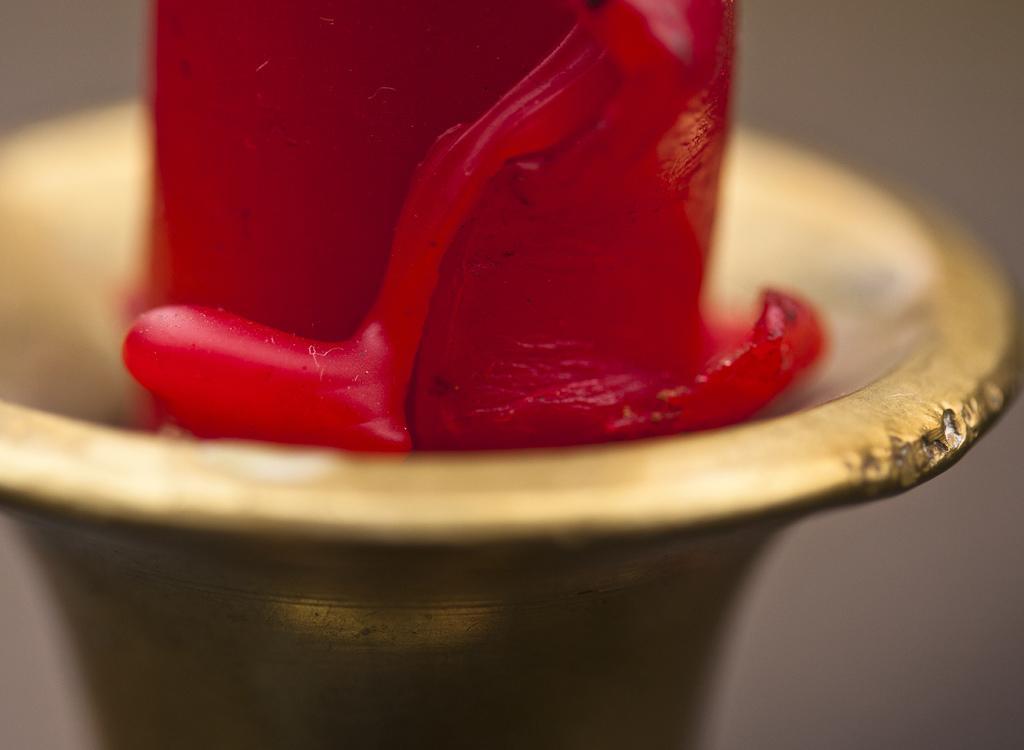Please provide a concise description of this image. In this image we can see the wax on a stand. 